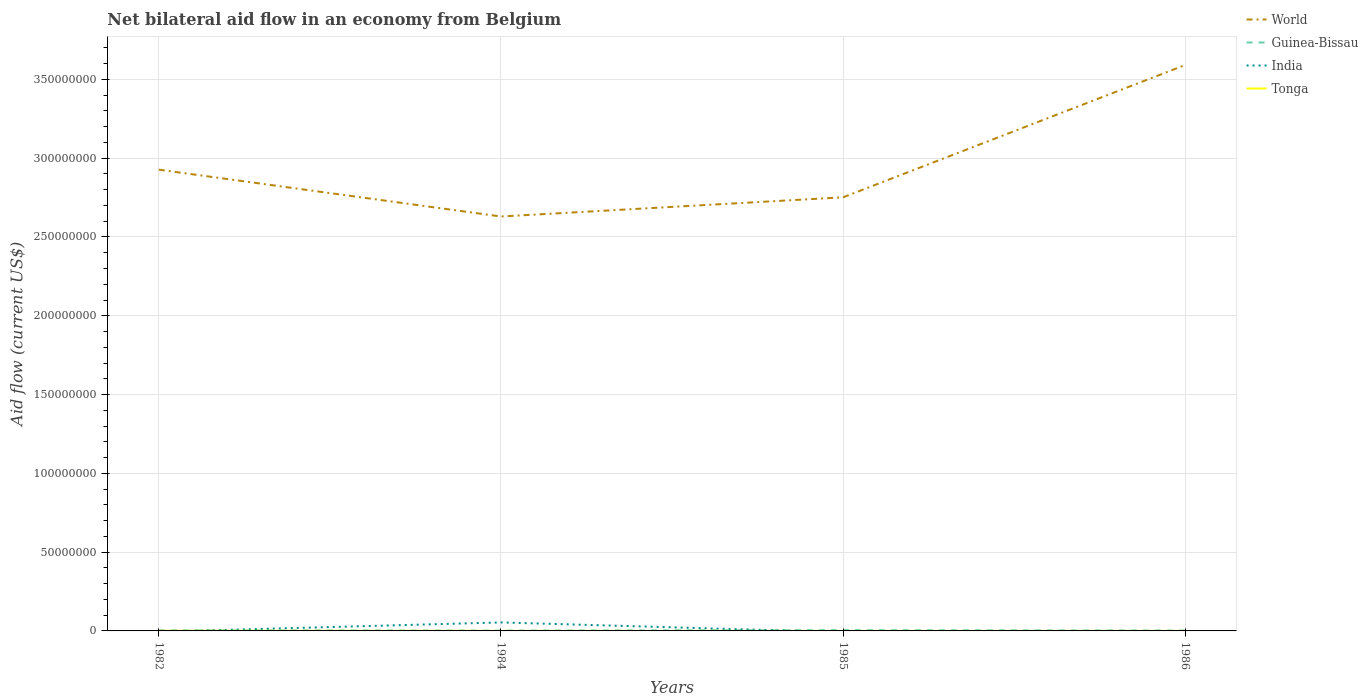Does the line corresponding to World intersect with the line corresponding to Guinea-Bissau?
Provide a short and direct response. No. Is the number of lines equal to the number of legend labels?
Your response must be concise. No. Across all years, what is the maximum net bilateral aid flow in World?
Offer a terse response. 2.63e+08. What is the total net bilateral aid flow in World in the graph?
Your answer should be very brief. 1.75e+07. What is the difference between the highest and the second highest net bilateral aid flow in India?
Your answer should be very brief. 5.39e+06. How many lines are there?
Provide a short and direct response. 4. How many years are there in the graph?
Provide a short and direct response. 4. What is the difference between two consecutive major ticks on the Y-axis?
Ensure brevity in your answer.  5.00e+07. Does the graph contain any zero values?
Offer a terse response. Yes. What is the title of the graph?
Offer a very short reply. Net bilateral aid flow in an economy from Belgium. Does "World" appear as one of the legend labels in the graph?
Give a very brief answer. Yes. What is the label or title of the X-axis?
Your answer should be compact. Years. What is the Aid flow (current US$) of World in 1982?
Your response must be concise. 2.93e+08. What is the Aid flow (current US$) in India in 1982?
Provide a short and direct response. 0. What is the Aid flow (current US$) of World in 1984?
Your answer should be compact. 2.63e+08. What is the Aid flow (current US$) of India in 1984?
Offer a very short reply. 5.39e+06. What is the Aid flow (current US$) in Tonga in 1984?
Give a very brief answer. 10000. What is the Aid flow (current US$) in World in 1985?
Your answer should be very brief. 2.75e+08. What is the Aid flow (current US$) in India in 1985?
Offer a terse response. 0. What is the Aid flow (current US$) in World in 1986?
Offer a terse response. 3.59e+08. What is the Aid flow (current US$) in Guinea-Bissau in 1986?
Offer a terse response. 2.40e+05. Across all years, what is the maximum Aid flow (current US$) in World?
Provide a succinct answer. 3.59e+08. Across all years, what is the maximum Aid flow (current US$) in India?
Give a very brief answer. 5.39e+06. Across all years, what is the minimum Aid flow (current US$) of World?
Offer a very short reply. 2.63e+08. What is the total Aid flow (current US$) of World in the graph?
Offer a terse response. 1.19e+09. What is the total Aid flow (current US$) of Guinea-Bissau in the graph?
Your answer should be compact. 1.28e+06. What is the total Aid flow (current US$) of India in the graph?
Ensure brevity in your answer.  5.39e+06. What is the difference between the Aid flow (current US$) of World in 1982 and that in 1984?
Provide a short and direct response. 2.97e+07. What is the difference between the Aid flow (current US$) of Tonga in 1982 and that in 1984?
Provide a short and direct response. 6.00e+04. What is the difference between the Aid flow (current US$) of World in 1982 and that in 1985?
Your answer should be compact. 1.75e+07. What is the difference between the Aid flow (current US$) of Guinea-Bissau in 1982 and that in 1985?
Make the answer very short. -1.60e+05. What is the difference between the Aid flow (current US$) in Tonga in 1982 and that in 1985?
Your response must be concise. 6.00e+04. What is the difference between the Aid flow (current US$) of World in 1982 and that in 1986?
Give a very brief answer. -6.64e+07. What is the difference between the Aid flow (current US$) of Guinea-Bissau in 1982 and that in 1986?
Ensure brevity in your answer.  1.00e+05. What is the difference between the Aid flow (current US$) of Tonga in 1982 and that in 1986?
Your answer should be very brief. 6.00e+04. What is the difference between the Aid flow (current US$) in World in 1984 and that in 1985?
Offer a terse response. -1.22e+07. What is the difference between the Aid flow (current US$) of Guinea-Bissau in 1984 and that in 1985?
Your response must be concise. -3.00e+05. What is the difference between the Aid flow (current US$) of Tonga in 1984 and that in 1985?
Ensure brevity in your answer.  0. What is the difference between the Aid flow (current US$) in World in 1984 and that in 1986?
Ensure brevity in your answer.  -9.61e+07. What is the difference between the Aid flow (current US$) in World in 1985 and that in 1986?
Provide a succinct answer. -8.40e+07. What is the difference between the Aid flow (current US$) of World in 1982 and the Aid flow (current US$) of Guinea-Bissau in 1984?
Keep it short and to the point. 2.93e+08. What is the difference between the Aid flow (current US$) in World in 1982 and the Aid flow (current US$) in India in 1984?
Your response must be concise. 2.87e+08. What is the difference between the Aid flow (current US$) in World in 1982 and the Aid flow (current US$) in Tonga in 1984?
Your answer should be very brief. 2.93e+08. What is the difference between the Aid flow (current US$) in Guinea-Bissau in 1982 and the Aid flow (current US$) in India in 1984?
Provide a succinct answer. -5.05e+06. What is the difference between the Aid flow (current US$) in World in 1982 and the Aid flow (current US$) in Guinea-Bissau in 1985?
Offer a very short reply. 2.92e+08. What is the difference between the Aid flow (current US$) in World in 1982 and the Aid flow (current US$) in Tonga in 1985?
Your response must be concise. 2.93e+08. What is the difference between the Aid flow (current US$) in World in 1982 and the Aid flow (current US$) in Guinea-Bissau in 1986?
Your answer should be compact. 2.92e+08. What is the difference between the Aid flow (current US$) of World in 1982 and the Aid flow (current US$) of Tonga in 1986?
Provide a succinct answer. 2.93e+08. What is the difference between the Aid flow (current US$) in Guinea-Bissau in 1982 and the Aid flow (current US$) in Tonga in 1986?
Give a very brief answer. 3.30e+05. What is the difference between the Aid flow (current US$) in World in 1984 and the Aid flow (current US$) in Guinea-Bissau in 1985?
Your answer should be compact. 2.63e+08. What is the difference between the Aid flow (current US$) of World in 1984 and the Aid flow (current US$) of Tonga in 1985?
Ensure brevity in your answer.  2.63e+08. What is the difference between the Aid flow (current US$) of Guinea-Bissau in 1984 and the Aid flow (current US$) of Tonga in 1985?
Make the answer very short. 1.90e+05. What is the difference between the Aid flow (current US$) in India in 1984 and the Aid flow (current US$) in Tonga in 1985?
Make the answer very short. 5.38e+06. What is the difference between the Aid flow (current US$) in World in 1984 and the Aid flow (current US$) in Guinea-Bissau in 1986?
Provide a succinct answer. 2.63e+08. What is the difference between the Aid flow (current US$) in World in 1984 and the Aid flow (current US$) in Tonga in 1986?
Offer a terse response. 2.63e+08. What is the difference between the Aid flow (current US$) in India in 1984 and the Aid flow (current US$) in Tonga in 1986?
Offer a very short reply. 5.38e+06. What is the difference between the Aid flow (current US$) in World in 1985 and the Aid flow (current US$) in Guinea-Bissau in 1986?
Your response must be concise. 2.75e+08. What is the difference between the Aid flow (current US$) in World in 1985 and the Aid flow (current US$) in Tonga in 1986?
Provide a short and direct response. 2.75e+08. What is the difference between the Aid flow (current US$) in Guinea-Bissau in 1985 and the Aid flow (current US$) in Tonga in 1986?
Keep it short and to the point. 4.90e+05. What is the average Aid flow (current US$) in World per year?
Provide a succinct answer. 2.98e+08. What is the average Aid flow (current US$) in Guinea-Bissau per year?
Offer a terse response. 3.20e+05. What is the average Aid flow (current US$) in India per year?
Ensure brevity in your answer.  1.35e+06. What is the average Aid flow (current US$) of Tonga per year?
Provide a short and direct response. 2.50e+04. In the year 1982, what is the difference between the Aid flow (current US$) in World and Aid flow (current US$) in Guinea-Bissau?
Give a very brief answer. 2.92e+08. In the year 1982, what is the difference between the Aid flow (current US$) in World and Aid flow (current US$) in Tonga?
Make the answer very short. 2.93e+08. In the year 1982, what is the difference between the Aid flow (current US$) in Guinea-Bissau and Aid flow (current US$) in Tonga?
Your response must be concise. 2.70e+05. In the year 1984, what is the difference between the Aid flow (current US$) in World and Aid flow (current US$) in Guinea-Bissau?
Make the answer very short. 2.63e+08. In the year 1984, what is the difference between the Aid flow (current US$) of World and Aid flow (current US$) of India?
Give a very brief answer. 2.58e+08. In the year 1984, what is the difference between the Aid flow (current US$) of World and Aid flow (current US$) of Tonga?
Your answer should be very brief. 2.63e+08. In the year 1984, what is the difference between the Aid flow (current US$) of Guinea-Bissau and Aid flow (current US$) of India?
Offer a terse response. -5.19e+06. In the year 1984, what is the difference between the Aid flow (current US$) in India and Aid flow (current US$) in Tonga?
Your answer should be very brief. 5.38e+06. In the year 1985, what is the difference between the Aid flow (current US$) in World and Aid flow (current US$) in Guinea-Bissau?
Offer a very short reply. 2.75e+08. In the year 1985, what is the difference between the Aid flow (current US$) in World and Aid flow (current US$) in Tonga?
Your answer should be compact. 2.75e+08. In the year 1986, what is the difference between the Aid flow (current US$) in World and Aid flow (current US$) in Guinea-Bissau?
Provide a succinct answer. 3.59e+08. In the year 1986, what is the difference between the Aid flow (current US$) in World and Aid flow (current US$) in Tonga?
Ensure brevity in your answer.  3.59e+08. What is the ratio of the Aid flow (current US$) in World in 1982 to that in 1984?
Your answer should be compact. 1.11. What is the ratio of the Aid flow (current US$) in Guinea-Bissau in 1982 to that in 1984?
Your response must be concise. 1.7. What is the ratio of the Aid flow (current US$) in Tonga in 1982 to that in 1984?
Give a very brief answer. 7. What is the ratio of the Aid flow (current US$) in World in 1982 to that in 1985?
Give a very brief answer. 1.06. What is the ratio of the Aid flow (current US$) of Guinea-Bissau in 1982 to that in 1985?
Ensure brevity in your answer.  0.68. What is the ratio of the Aid flow (current US$) in World in 1982 to that in 1986?
Offer a very short reply. 0.82. What is the ratio of the Aid flow (current US$) in Guinea-Bissau in 1982 to that in 1986?
Your answer should be compact. 1.42. What is the ratio of the Aid flow (current US$) in Tonga in 1982 to that in 1986?
Provide a short and direct response. 7. What is the ratio of the Aid flow (current US$) of World in 1984 to that in 1985?
Offer a terse response. 0.96. What is the ratio of the Aid flow (current US$) of Guinea-Bissau in 1984 to that in 1985?
Give a very brief answer. 0.4. What is the ratio of the Aid flow (current US$) in Tonga in 1984 to that in 1985?
Ensure brevity in your answer.  1. What is the ratio of the Aid flow (current US$) in World in 1984 to that in 1986?
Keep it short and to the point. 0.73. What is the ratio of the Aid flow (current US$) of Guinea-Bissau in 1984 to that in 1986?
Provide a short and direct response. 0.83. What is the ratio of the Aid flow (current US$) of Tonga in 1984 to that in 1986?
Provide a short and direct response. 1. What is the ratio of the Aid flow (current US$) in World in 1985 to that in 1986?
Give a very brief answer. 0.77. What is the ratio of the Aid flow (current US$) of Guinea-Bissau in 1985 to that in 1986?
Provide a short and direct response. 2.08. What is the difference between the highest and the second highest Aid flow (current US$) in World?
Your answer should be very brief. 6.64e+07. What is the difference between the highest and the second highest Aid flow (current US$) of Tonga?
Offer a terse response. 6.00e+04. What is the difference between the highest and the lowest Aid flow (current US$) in World?
Provide a short and direct response. 9.61e+07. What is the difference between the highest and the lowest Aid flow (current US$) in India?
Your answer should be very brief. 5.39e+06. What is the difference between the highest and the lowest Aid flow (current US$) in Tonga?
Make the answer very short. 6.00e+04. 